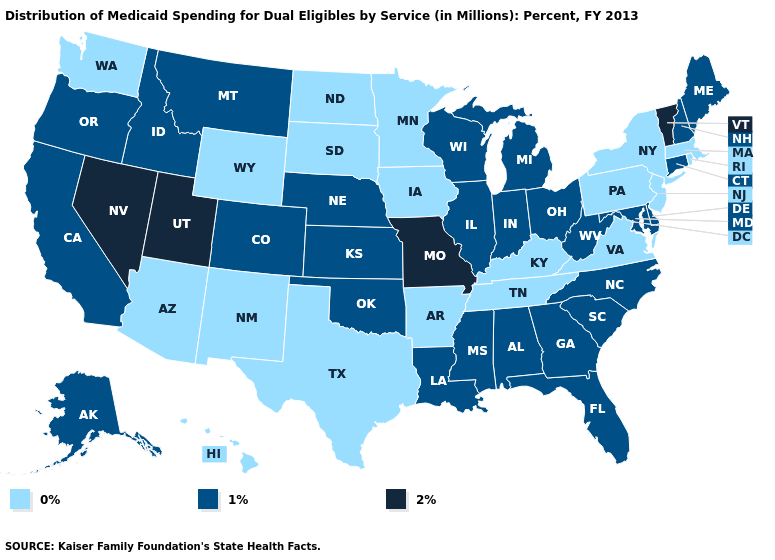Does Nebraska have the highest value in the MidWest?
Write a very short answer. No. Name the states that have a value in the range 0%?
Keep it brief. Arizona, Arkansas, Hawaii, Iowa, Kentucky, Massachusetts, Minnesota, New Jersey, New Mexico, New York, North Dakota, Pennsylvania, Rhode Island, South Dakota, Tennessee, Texas, Virginia, Washington, Wyoming. Does the first symbol in the legend represent the smallest category?
Quick response, please. Yes. Name the states that have a value in the range 2%?
Short answer required. Missouri, Nevada, Utah, Vermont. Does Ohio have a lower value than Vermont?
Give a very brief answer. Yes. Does California have the lowest value in the USA?
Give a very brief answer. No. Name the states that have a value in the range 2%?
Give a very brief answer. Missouri, Nevada, Utah, Vermont. What is the value of Michigan?
Short answer required. 1%. Does North Carolina have a lower value than Utah?
Concise answer only. Yes. How many symbols are there in the legend?
Write a very short answer. 3. Name the states that have a value in the range 2%?
Quick response, please. Missouri, Nevada, Utah, Vermont. Does South Carolina have a higher value than New Hampshire?
Be succinct. No. Among the states that border Oregon , which have the highest value?
Give a very brief answer. Nevada. Does Indiana have the lowest value in the MidWest?
Answer briefly. No. Name the states that have a value in the range 1%?
Answer briefly. Alabama, Alaska, California, Colorado, Connecticut, Delaware, Florida, Georgia, Idaho, Illinois, Indiana, Kansas, Louisiana, Maine, Maryland, Michigan, Mississippi, Montana, Nebraska, New Hampshire, North Carolina, Ohio, Oklahoma, Oregon, South Carolina, West Virginia, Wisconsin. 